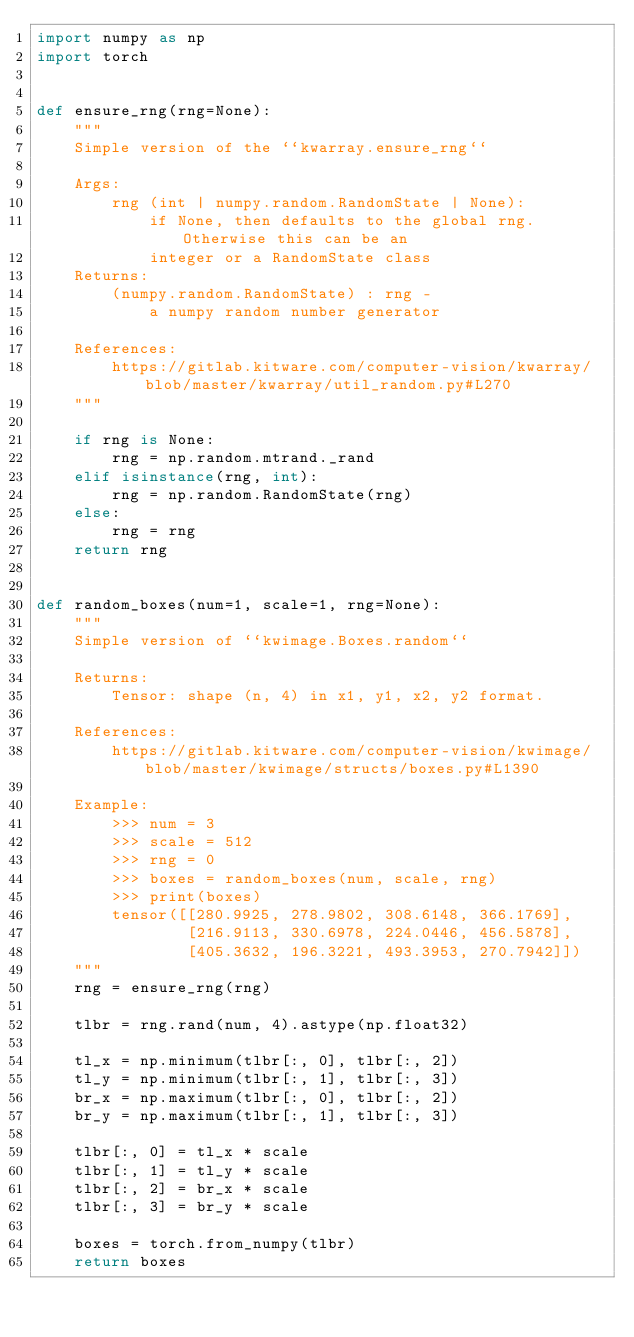<code> <loc_0><loc_0><loc_500><loc_500><_Python_>import numpy as np
import torch


def ensure_rng(rng=None):
    """
    Simple version of the ``kwarray.ensure_rng``

    Args:
        rng (int | numpy.random.RandomState | None):
            if None, then defaults to the global rng. Otherwise this can be an
            integer or a RandomState class
    Returns:
        (numpy.random.RandomState) : rng -
            a numpy random number generator

    References:
        https://gitlab.kitware.com/computer-vision/kwarray/blob/master/kwarray/util_random.py#L270
    """

    if rng is None:
        rng = np.random.mtrand._rand
    elif isinstance(rng, int):
        rng = np.random.RandomState(rng)
    else:
        rng = rng
    return rng


def random_boxes(num=1, scale=1, rng=None):
    """
    Simple version of ``kwimage.Boxes.random``

    Returns:
        Tensor: shape (n, 4) in x1, y1, x2, y2 format.

    References:
        https://gitlab.kitware.com/computer-vision/kwimage/blob/master/kwimage/structs/boxes.py#L1390

    Example:
        >>> num = 3
        >>> scale = 512
        >>> rng = 0
        >>> boxes = random_boxes(num, scale, rng)
        >>> print(boxes)
        tensor([[280.9925, 278.9802, 308.6148, 366.1769],
                [216.9113, 330.6978, 224.0446, 456.5878],
                [405.3632, 196.3221, 493.3953, 270.7942]])
    """
    rng = ensure_rng(rng)

    tlbr = rng.rand(num, 4).astype(np.float32)

    tl_x = np.minimum(tlbr[:, 0], tlbr[:, 2])
    tl_y = np.minimum(tlbr[:, 1], tlbr[:, 3])
    br_x = np.maximum(tlbr[:, 0], tlbr[:, 2])
    br_y = np.maximum(tlbr[:, 1], tlbr[:, 3])

    tlbr[:, 0] = tl_x * scale
    tlbr[:, 1] = tl_y * scale
    tlbr[:, 2] = br_x * scale
    tlbr[:, 3] = br_y * scale

    boxes = torch.from_numpy(tlbr)
    return boxes
</code> 